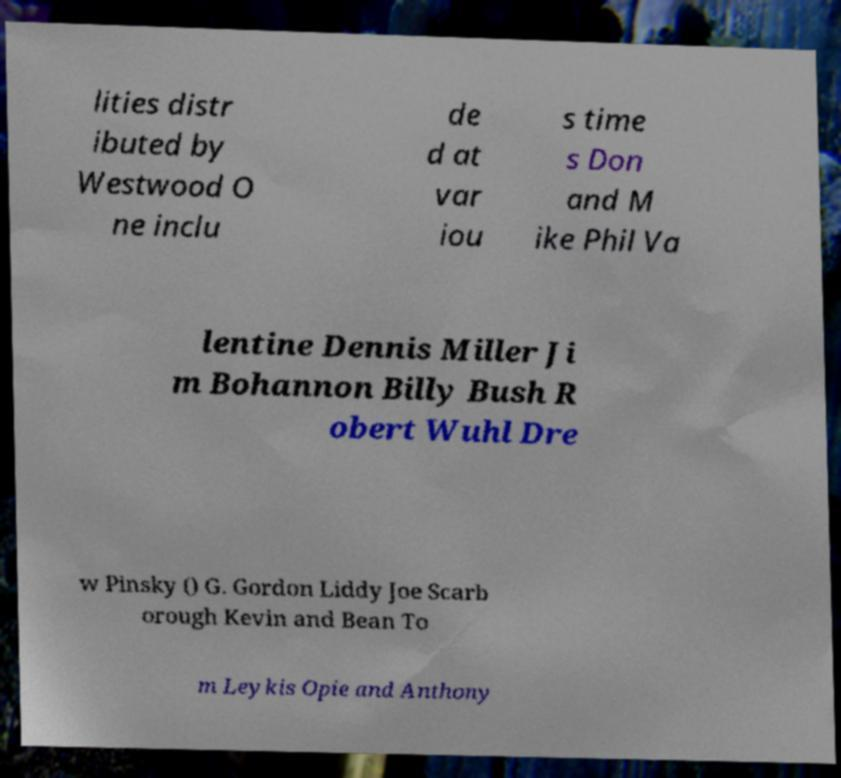Please identify and transcribe the text found in this image. lities distr ibuted by Westwood O ne inclu de d at var iou s time s Don and M ike Phil Va lentine Dennis Miller Ji m Bohannon Billy Bush R obert Wuhl Dre w Pinsky () G. Gordon Liddy Joe Scarb orough Kevin and Bean To m Leykis Opie and Anthony 